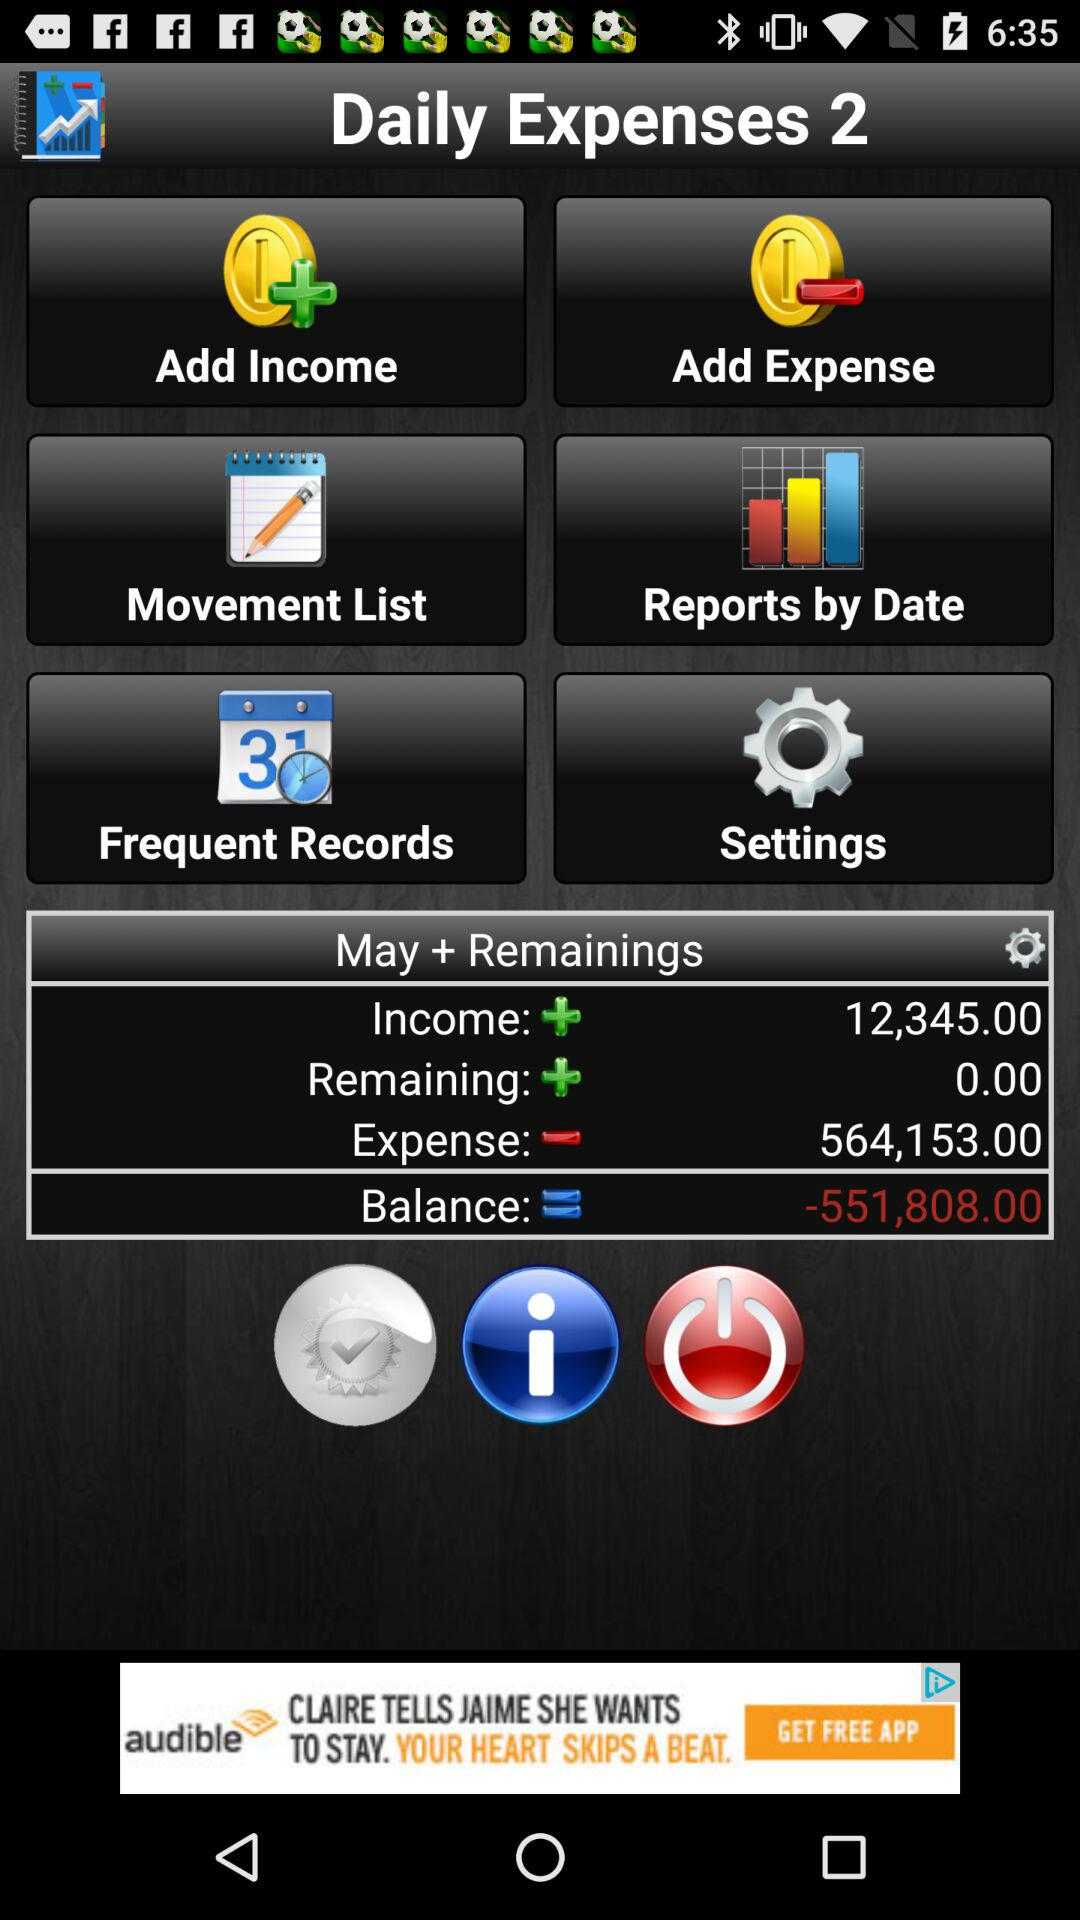How much is the total expense? The total expense is 564,153.00. 